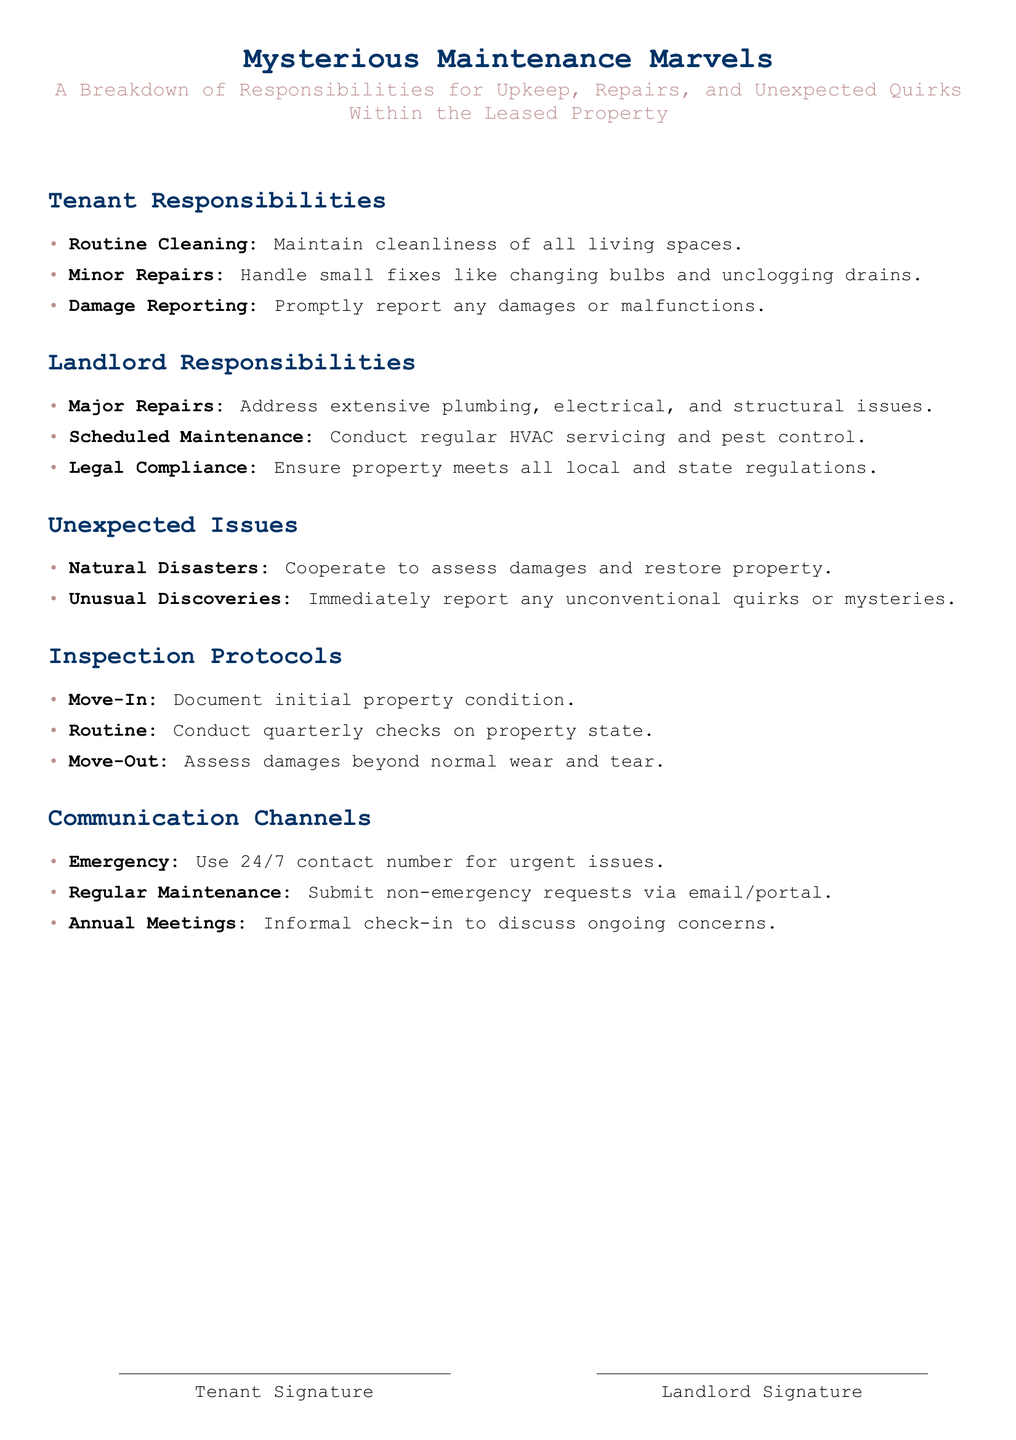What are the tenant's cleaning responsibilities? The document specifies that the tenant must maintain cleanliness of all living spaces.
Answer: Routine Cleaning What major issues does the landlord handle? The document outlines that the landlord is responsible for addressing extensive plumbing, electrical, and structural issues.
Answer: Major Repairs How often are routine inspections conducted? The document states that routine inspections happen quarterly to assess the property state.
Answer: Quarterly What should be done in case of unusual discoveries? According to the document, any unconventional quirks or mysteries should be immediately reported.
Answer: Report What is one communication channel for emergencies? The document indicates that tenants should use a 24/7 contact number for urgent issues.
Answer: Emergency What happens during the move-out inspection? It involves assessing damages beyond normal wear and tear, as mentioned in the document.
Answer: Assess damages 